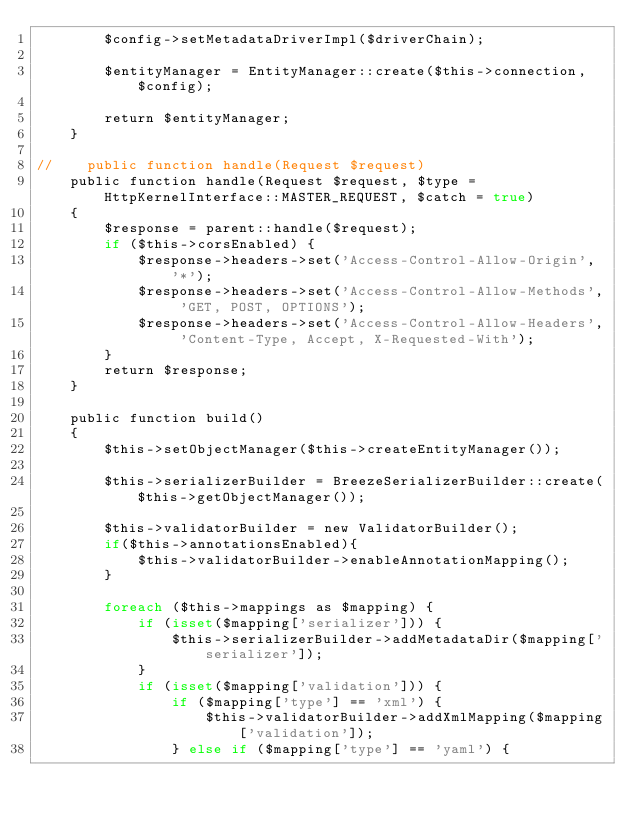Convert code to text. <code><loc_0><loc_0><loc_500><loc_500><_PHP_>        $config->setMetadataDriverImpl($driverChain);

        $entityManager = EntityManager::create($this->connection, $config);

        return $entityManager;
    }

//    public function handle(Request $request)
    public function handle(Request $request, $type = HttpKernelInterface::MASTER_REQUEST, $catch = true)
    {
        $response = parent::handle($request);
        if ($this->corsEnabled) {
            $response->headers->set('Access-Control-Allow-Origin', '*');
            $response->headers->set('Access-Control-Allow-Methods', 'GET, POST, OPTIONS');
            $response->headers->set('Access-Control-Allow-Headers', 'Content-Type, Accept, X-Requested-With');
        }
        return $response;
    }

    public function build()
    {
        $this->setObjectManager($this->createEntityManager());

        $this->serializerBuilder = BreezeSerializerBuilder::create($this->getObjectManager());

        $this->validatorBuilder = new ValidatorBuilder();
        if($this->annotationsEnabled){
            $this->validatorBuilder->enableAnnotationMapping();
        }

        foreach ($this->mappings as $mapping) {
            if (isset($mapping['serializer'])) {
                $this->serializerBuilder->addMetadataDir($mapping['serializer']);
            }
            if (isset($mapping['validation'])) {
                if ($mapping['type'] == 'xml') {
                    $this->validatorBuilder->addXmlMapping($mapping['validation']);
                } else if ($mapping['type'] == 'yaml') {</code> 